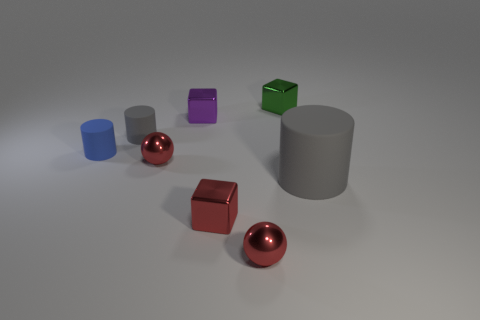What number of spheres are shiny things or small purple things?
Offer a terse response. 2. Is the size of the red shiny block in front of the small gray cylinder the same as the gray thing to the left of the tiny green metal cube?
Your answer should be compact. Yes. What material is the block in front of the small cylinder in front of the small gray cylinder?
Your response must be concise. Metal. Is the number of gray cylinders that are on the right side of the big matte cylinder less than the number of tiny yellow metallic cylinders?
Offer a very short reply. No. What is the shape of the other small object that is the same material as the tiny blue thing?
Your answer should be compact. Cylinder. What number of other objects are there of the same shape as the blue rubber thing?
Offer a terse response. 2. What number of gray things are either small rubber cylinders or rubber cylinders?
Your response must be concise. 2. Do the large gray matte object and the purple thing have the same shape?
Your answer should be compact. No. Are there any small green objects that are right of the matte object that is to the right of the green shiny thing?
Offer a terse response. No. Are there an equal number of tiny rubber things right of the purple thing and gray rubber things?
Ensure brevity in your answer.  No. 